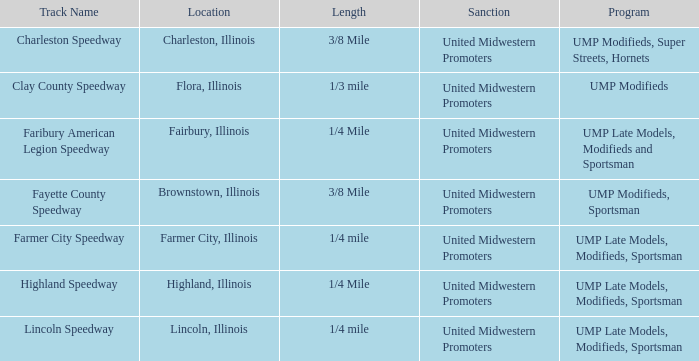What programs were held at highland speedway? UMP Late Models, Modifieds, Sportsman. 